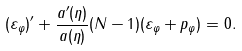Convert formula to latex. <formula><loc_0><loc_0><loc_500><loc_500>( \varepsilon _ { \varphi } ) ^ { \prime } + \frac { a ^ { \prime } ( \eta ) } { a ( \eta ) } ( N - 1 ) ( \varepsilon _ { \varphi } + p _ { \varphi } ) = 0 .</formula> 